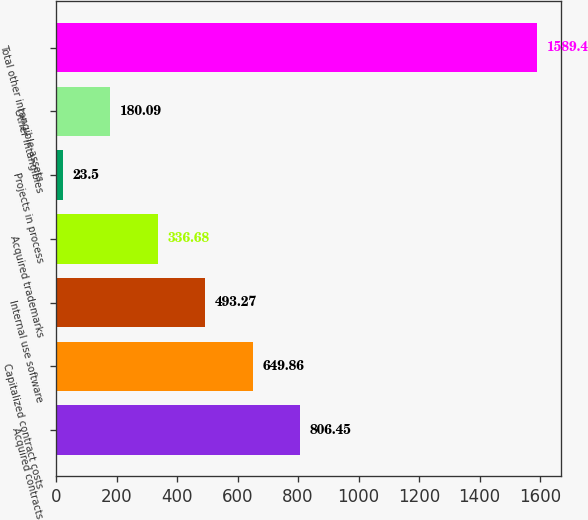Convert chart. <chart><loc_0><loc_0><loc_500><loc_500><bar_chart><fcel>Acquired contracts<fcel>Capitalized contract costs<fcel>Internal use software<fcel>Acquired trademarks<fcel>Projects in process<fcel>Other intangibles<fcel>Total other intangible assets<nl><fcel>806.45<fcel>649.86<fcel>493.27<fcel>336.68<fcel>23.5<fcel>180.09<fcel>1589.4<nl></chart> 